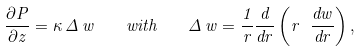<formula> <loc_0><loc_0><loc_500><loc_500>\frac { \partial P } { \partial z } = \kappa \, \Delta \, w \quad w i t h \quad \Delta \, w = \frac { 1 } { r } \frac { d } { d r } \left ( r \ \frac { d w } { d r } \right ) ,</formula> 